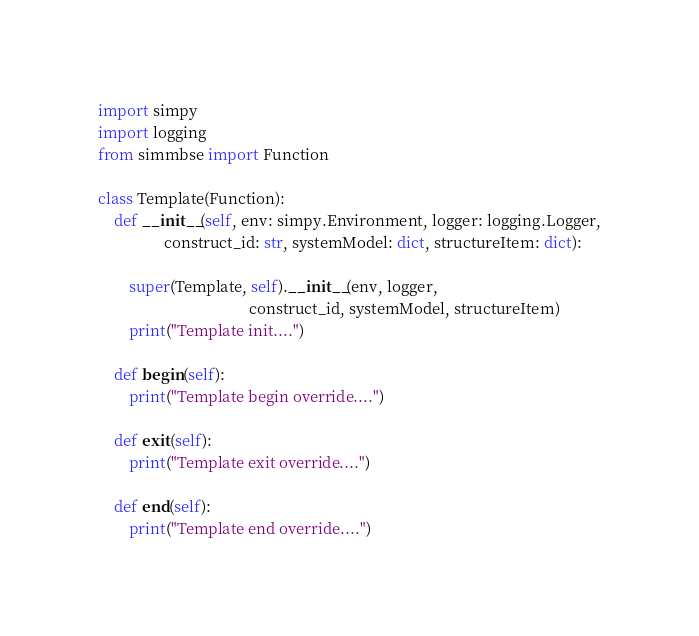<code> <loc_0><loc_0><loc_500><loc_500><_Python_>import simpy
import logging
from simmbse import Function

class Template(Function):
    def __init__(self, env: simpy.Environment, logger: logging.Logger,
                 construct_id: str, systemModel: dict, structureItem: dict):

        super(Template, self).__init__(env, logger,
                                       construct_id, systemModel, structureItem)
        print("Template init....")

    def begin(self):
        print("Template begin override....")

    def exit(self):
        print("Template exit override....")

    def end(self):
        print("Template end override....")</code> 